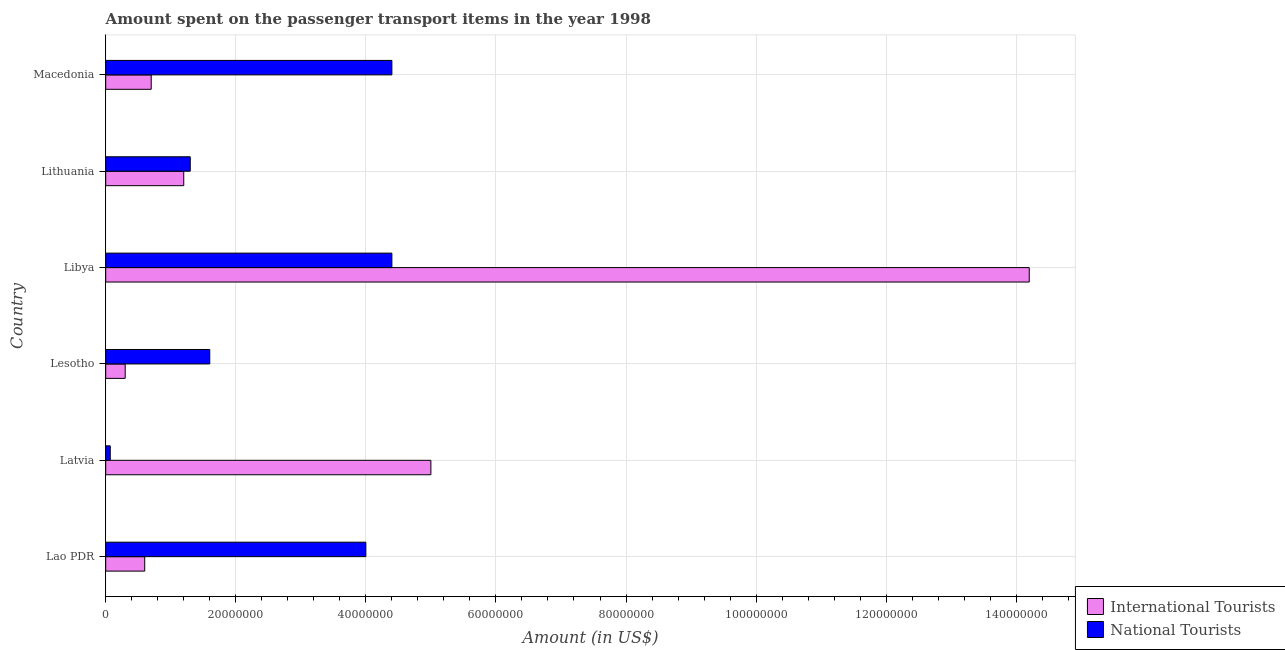How many groups of bars are there?
Offer a terse response. 6. Are the number of bars on each tick of the Y-axis equal?
Your response must be concise. Yes. How many bars are there on the 3rd tick from the bottom?
Provide a succinct answer. 2. What is the label of the 2nd group of bars from the top?
Ensure brevity in your answer.  Lithuania. In how many cases, is the number of bars for a given country not equal to the number of legend labels?
Your response must be concise. 0. Across all countries, what is the maximum amount spent on transport items of international tourists?
Your answer should be very brief. 1.42e+08. Across all countries, what is the minimum amount spent on transport items of national tourists?
Give a very brief answer. 7.00e+05. In which country was the amount spent on transport items of national tourists maximum?
Make the answer very short. Libya. In which country was the amount spent on transport items of international tourists minimum?
Your answer should be very brief. Lesotho. What is the total amount spent on transport items of international tourists in the graph?
Keep it short and to the point. 2.20e+08. What is the average amount spent on transport items of international tourists per country?
Keep it short and to the point. 3.67e+07. In how many countries, is the amount spent on transport items of national tourists greater than 120000000 US$?
Keep it short and to the point. 0. What is the ratio of the amount spent on transport items of international tourists in Latvia to that in Libya?
Provide a short and direct response. 0.35. Is the difference between the amount spent on transport items of international tourists in Lithuania and Macedonia greater than the difference between the amount spent on transport items of national tourists in Lithuania and Macedonia?
Your answer should be very brief. Yes. What is the difference between the highest and the second highest amount spent on transport items of international tourists?
Give a very brief answer. 9.20e+07. What is the difference between the highest and the lowest amount spent on transport items of national tourists?
Keep it short and to the point. 4.33e+07. Is the sum of the amount spent on transport items of national tourists in Libya and Lithuania greater than the maximum amount spent on transport items of international tourists across all countries?
Your response must be concise. No. What does the 2nd bar from the top in Lithuania represents?
Provide a short and direct response. International Tourists. What does the 2nd bar from the bottom in Lao PDR represents?
Ensure brevity in your answer.  National Tourists. Are all the bars in the graph horizontal?
Your response must be concise. Yes. What is the difference between two consecutive major ticks on the X-axis?
Ensure brevity in your answer.  2.00e+07. Does the graph contain grids?
Offer a terse response. Yes. How many legend labels are there?
Make the answer very short. 2. What is the title of the graph?
Your answer should be compact. Amount spent on the passenger transport items in the year 1998. What is the label or title of the Y-axis?
Ensure brevity in your answer.  Country. What is the Amount (in US$) of International Tourists in Lao PDR?
Your answer should be compact. 6.00e+06. What is the Amount (in US$) of National Tourists in Lao PDR?
Ensure brevity in your answer.  4.00e+07. What is the Amount (in US$) of National Tourists in Lesotho?
Provide a short and direct response. 1.60e+07. What is the Amount (in US$) of International Tourists in Libya?
Your answer should be compact. 1.42e+08. What is the Amount (in US$) of National Tourists in Libya?
Your response must be concise. 4.40e+07. What is the Amount (in US$) in National Tourists in Lithuania?
Your answer should be very brief. 1.30e+07. What is the Amount (in US$) of National Tourists in Macedonia?
Ensure brevity in your answer.  4.40e+07. Across all countries, what is the maximum Amount (in US$) in International Tourists?
Provide a succinct answer. 1.42e+08. Across all countries, what is the maximum Amount (in US$) in National Tourists?
Give a very brief answer. 4.40e+07. What is the total Amount (in US$) in International Tourists in the graph?
Offer a very short reply. 2.20e+08. What is the total Amount (in US$) in National Tourists in the graph?
Your answer should be very brief. 1.58e+08. What is the difference between the Amount (in US$) in International Tourists in Lao PDR and that in Latvia?
Your answer should be compact. -4.40e+07. What is the difference between the Amount (in US$) in National Tourists in Lao PDR and that in Latvia?
Make the answer very short. 3.93e+07. What is the difference between the Amount (in US$) of National Tourists in Lao PDR and that in Lesotho?
Make the answer very short. 2.40e+07. What is the difference between the Amount (in US$) of International Tourists in Lao PDR and that in Libya?
Provide a succinct answer. -1.36e+08. What is the difference between the Amount (in US$) in National Tourists in Lao PDR and that in Libya?
Provide a succinct answer. -4.00e+06. What is the difference between the Amount (in US$) in International Tourists in Lao PDR and that in Lithuania?
Keep it short and to the point. -6.00e+06. What is the difference between the Amount (in US$) of National Tourists in Lao PDR and that in Lithuania?
Ensure brevity in your answer.  2.70e+07. What is the difference between the Amount (in US$) of International Tourists in Lao PDR and that in Macedonia?
Your answer should be compact. -1.00e+06. What is the difference between the Amount (in US$) in International Tourists in Latvia and that in Lesotho?
Provide a short and direct response. 4.70e+07. What is the difference between the Amount (in US$) of National Tourists in Latvia and that in Lesotho?
Your answer should be compact. -1.53e+07. What is the difference between the Amount (in US$) of International Tourists in Latvia and that in Libya?
Offer a terse response. -9.20e+07. What is the difference between the Amount (in US$) in National Tourists in Latvia and that in Libya?
Make the answer very short. -4.33e+07. What is the difference between the Amount (in US$) of International Tourists in Latvia and that in Lithuania?
Provide a short and direct response. 3.80e+07. What is the difference between the Amount (in US$) in National Tourists in Latvia and that in Lithuania?
Keep it short and to the point. -1.23e+07. What is the difference between the Amount (in US$) in International Tourists in Latvia and that in Macedonia?
Give a very brief answer. 4.30e+07. What is the difference between the Amount (in US$) in National Tourists in Latvia and that in Macedonia?
Provide a short and direct response. -4.33e+07. What is the difference between the Amount (in US$) in International Tourists in Lesotho and that in Libya?
Ensure brevity in your answer.  -1.39e+08. What is the difference between the Amount (in US$) in National Tourists in Lesotho and that in Libya?
Provide a succinct answer. -2.80e+07. What is the difference between the Amount (in US$) in International Tourists in Lesotho and that in Lithuania?
Your answer should be compact. -9.00e+06. What is the difference between the Amount (in US$) of International Tourists in Lesotho and that in Macedonia?
Your answer should be very brief. -4.00e+06. What is the difference between the Amount (in US$) in National Tourists in Lesotho and that in Macedonia?
Ensure brevity in your answer.  -2.80e+07. What is the difference between the Amount (in US$) of International Tourists in Libya and that in Lithuania?
Your response must be concise. 1.30e+08. What is the difference between the Amount (in US$) of National Tourists in Libya and that in Lithuania?
Your answer should be very brief. 3.10e+07. What is the difference between the Amount (in US$) of International Tourists in Libya and that in Macedonia?
Offer a terse response. 1.35e+08. What is the difference between the Amount (in US$) in National Tourists in Lithuania and that in Macedonia?
Give a very brief answer. -3.10e+07. What is the difference between the Amount (in US$) in International Tourists in Lao PDR and the Amount (in US$) in National Tourists in Latvia?
Make the answer very short. 5.30e+06. What is the difference between the Amount (in US$) of International Tourists in Lao PDR and the Amount (in US$) of National Tourists in Lesotho?
Offer a terse response. -1.00e+07. What is the difference between the Amount (in US$) of International Tourists in Lao PDR and the Amount (in US$) of National Tourists in Libya?
Make the answer very short. -3.80e+07. What is the difference between the Amount (in US$) of International Tourists in Lao PDR and the Amount (in US$) of National Tourists in Lithuania?
Keep it short and to the point. -7.00e+06. What is the difference between the Amount (in US$) of International Tourists in Lao PDR and the Amount (in US$) of National Tourists in Macedonia?
Your answer should be compact. -3.80e+07. What is the difference between the Amount (in US$) of International Tourists in Latvia and the Amount (in US$) of National Tourists in Lesotho?
Your answer should be very brief. 3.40e+07. What is the difference between the Amount (in US$) of International Tourists in Latvia and the Amount (in US$) of National Tourists in Libya?
Provide a succinct answer. 6.00e+06. What is the difference between the Amount (in US$) of International Tourists in Latvia and the Amount (in US$) of National Tourists in Lithuania?
Keep it short and to the point. 3.70e+07. What is the difference between the Amount (in US$) of International Tourists in Lesotho and the Amount (in US$) of National Tourists in Libya?
Your response must be concise. -4.10e+07. What is the difference between the Amount (in US$) of International Tourists in Lesotho and the Amount (in US$) of National Tourists in Lithuania?
Provide a short and direct response. -1.00e+07. What is the difference between the Amount (in US$) in International Tourists in Lesotho and the Amount (in US$) in National Tourists in Macedonia?
Your answer should be very brief. -4.10e+07. What is the difference between the Amount (in US$) in International Tourists in Libya and the Amount (in US$) in National Tourists in Lithuania?
Give a very brief answer. 1.29e+08. What is the difference between the Amount (in US$) in International Tourists in Libya and the Amount (in US$) in National Tourists in Macedonia?
Ensure brevity in your answer.  9.80e+07. What is the difference between the Amount (in US$) of International Tourists in Lithuania and the Amount (in US$) of National Tourists in Macedonia?
Offer a terse response. -3.20e+07. What is the average Amount (in US$) of International Tourists per country?
Keep it short and to the point. 3.67e+07. What is the average Amount (in US$) of National Tourists per country?
Your answer should be compact. 2.63e+07. What is the difference between the Amount (in US$) of International Tourists and Amount (in US$) of National Tourists in Lao PDR?
Ensure brevity in your answer.  -3.40e+07. What is the difference between the Amount (in US$) of International Tourists and Amount (in US$) of National Tourists in Latvia?
Offer a terse response. 4.93e+07. What is the difference between the Amount (in US$) in International Tourists and Amount (in US$) in National Tourists in Lesotho?
Your answer should be compact. -1.30e+07. What is the difference between the Amount (in US$) in International Tourists and Amount (in US$) in National Tourists in Libya?
Offer a terse response. 9.80e+07. What is the difference between the Amount (in US$) of International Tourists and Amount (in US$) of National Tourists in Lithuania?
Offer a terse response. -1.00e+06. What is the difference between the Amount (in US$) of International Tourists and Amount (in US$) of National Tourists in Macedonia?
Make the answer very short. -3.70e+07. What is the ratio of the Amount (in US$) in International Tourists in Lao PDR to that in Latvia?
Your response must be concise. 0.12. What is the ratio of the Amount (in US$) of National Tourists in Lao PDR to that in Latvia?
Your response must be concise. 57.14. What is the ratio of the Amount (in US$) in International Tourists in Lao PDR to that in Lesotho?
Ensure brevity in your answer.  2. What is the ratio of the Amount (in US$) in National Tourists in Lao PDR to that in Lesotho?
Provide a succinct answer. 2.5. What is the ratio of the Amount (in US$) in International Tourists in Lao PDR to that in Libya?
Your response must be concise. 0.04. What is the ratio of the Amount (in US$) of National Tourists in Lao PDR to that in Libya?
Ensure brevity in your answer.  0.91. What is the ratio of the Amount (in US$) in International Tourists in Lao PDR to that in Lithuania?
Your answer should be compact. 0.5. What is the ratio of the Amount (in US$) in National Tourists in Lao PDR to that in Lithuania?
Your response must be concise. 3.08. What is the ratio of the Amount (in US$) of International Tourists in Lao PDR to that in Macedonia?
Make the answer very short. 0.86. What is the ratio of the Amount (in US$) of National Tourists in Lao PDR to that in Macedonia?
Offer a terse response. 0.91. What is the ratio of the Amount (in US$) in International Tourists in Latvia to that in Lesotho?
Your answer should be very brief. 16.67. What is the ratio of the Amount (in US$) of National Tourists in Latvia to that in Lesotho?
Make the answer very short. 0.04. What is the ratio of the Amount (in US$) in International Tourists in Latvia to that in Libya?
Provide a succinct answer. 0.35. What is the ratio of the Amount (in US$) in National Tourists in Latvia to that in Libya?
Offer a terse response. 0.02. What is the ratio of the Amount (in US$) of International Tourists in Latvia to that in Lithuania?
Your response must be concise. 4.17. What is the ratio of the Amount (in US$) of National Tourists in Latvia to that in Lithuania?
Ensure brevity in your answer.  0.05. What is the ratio of the Amount (in US$) of International Tourists in Latvia to that in Macedonia?
Ensure brevity in your answer.  7.14. What is the ratio of the Amount (in US$) in National Tourists in Latvia to that in Macedonia?
Your answer should be compact. 0.02. What is the ratio of the Amount (in US$) of International Tourists in Lesotho to that in Libya?
Your response must be concise. 0.02. What is the ratio of the Amount (in US$) in National Tourists in Lesotho to that in Libya?
Offer a terse response. 0.36. What is the ratio of the Amount (in US$) of National Tourists in Lesotho to that in Lithuania?
Provide a short and direct response. 1.23. What is the ratio of the Amount (in US$) in International Tourists in Lesotho to that in Macedonia?
Make the answer very short. 0.43. What is the ratio of the Amount (in US$) in National Tourists in Lesotho to that in Macedonia?
Offer a very short reply. 0.36. What is the ratio of the Amount (in US$) in International Tourists in Libya to that in Lithuania?
Offer a very short reply. 11.83. What is the ratio of the Amount (in US$) in National Tourists in Libya to that in Lithuania?
Make the answer very short. 3.38. What is the ratio of the Amount (in US$) of International Tourists in Libya to that in Macedonia?
Offer a terse response. 20.29. What is the ratio of the Amount (in US$) of International Tourists in Lithuania to that in Macedonia?
Provide a short and direct response. 1.71. What is the ratio of the Amount (in US$) in National Tourists in Lithuania to that in Macedonia?
Your answer should be very brief. 0.3. What is the difference between the highest and the second highest Amount (in US$) in International Tourists?
Provide a succinct answer. 9.20e+07. What is the difference between the highest and the second highest Amount (in US$) of National Tourists?
Ensure brevity in your answer.  0. What is the difference between the highest and the lowest Amount (in US$) of International Tourists?
Offer a very short reply. 1.39e+08. What is the difference between the highest and the lowest Amount (in US$) in National Tourists?
Make the answer very short. 4.33e+07. 